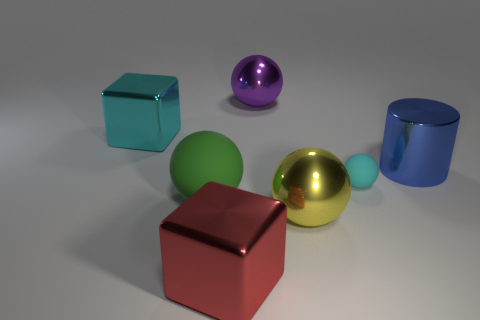There is a thing that is the same color as the small ball; what size is it?
Give a very brief answer. Large. Are there fewer large yellow metal objects that are in front of the large red block than red things?
Offer a very short reply. Yes. There is a metal ball in front of the large blue shiny cylinder; what number of green rubber spheres are to the right of it?
Give a very brief answer. 0. What number of other things are there of the same size as the yellow metallic sphere?
Provide a succinct answer. 5. What number of things are blue cylinders or metallic blocks to the right of the big cyan object?
Make the answer very short. 2. Is the number of large blue matte cylinders less than the number of big yellow things?
Provide a succinct answer. Yes. What color is the large metal thing that is on the left side of the big sphere to the left of the big red shiny thing?
Your response must be concise. Cyan. What material is the large green thing that is the same shape as the big purple metallic object?
Give a very brief answer. Rubber. What number of metal objects are either cyan spheres or large cyan objects?
Ensure brevity in your answer.  1. Is the big cube in front of the yellow object made of the same material as the big sphere that is behind the large shiny cylinder?
Keep it short and to the point. Yes. 